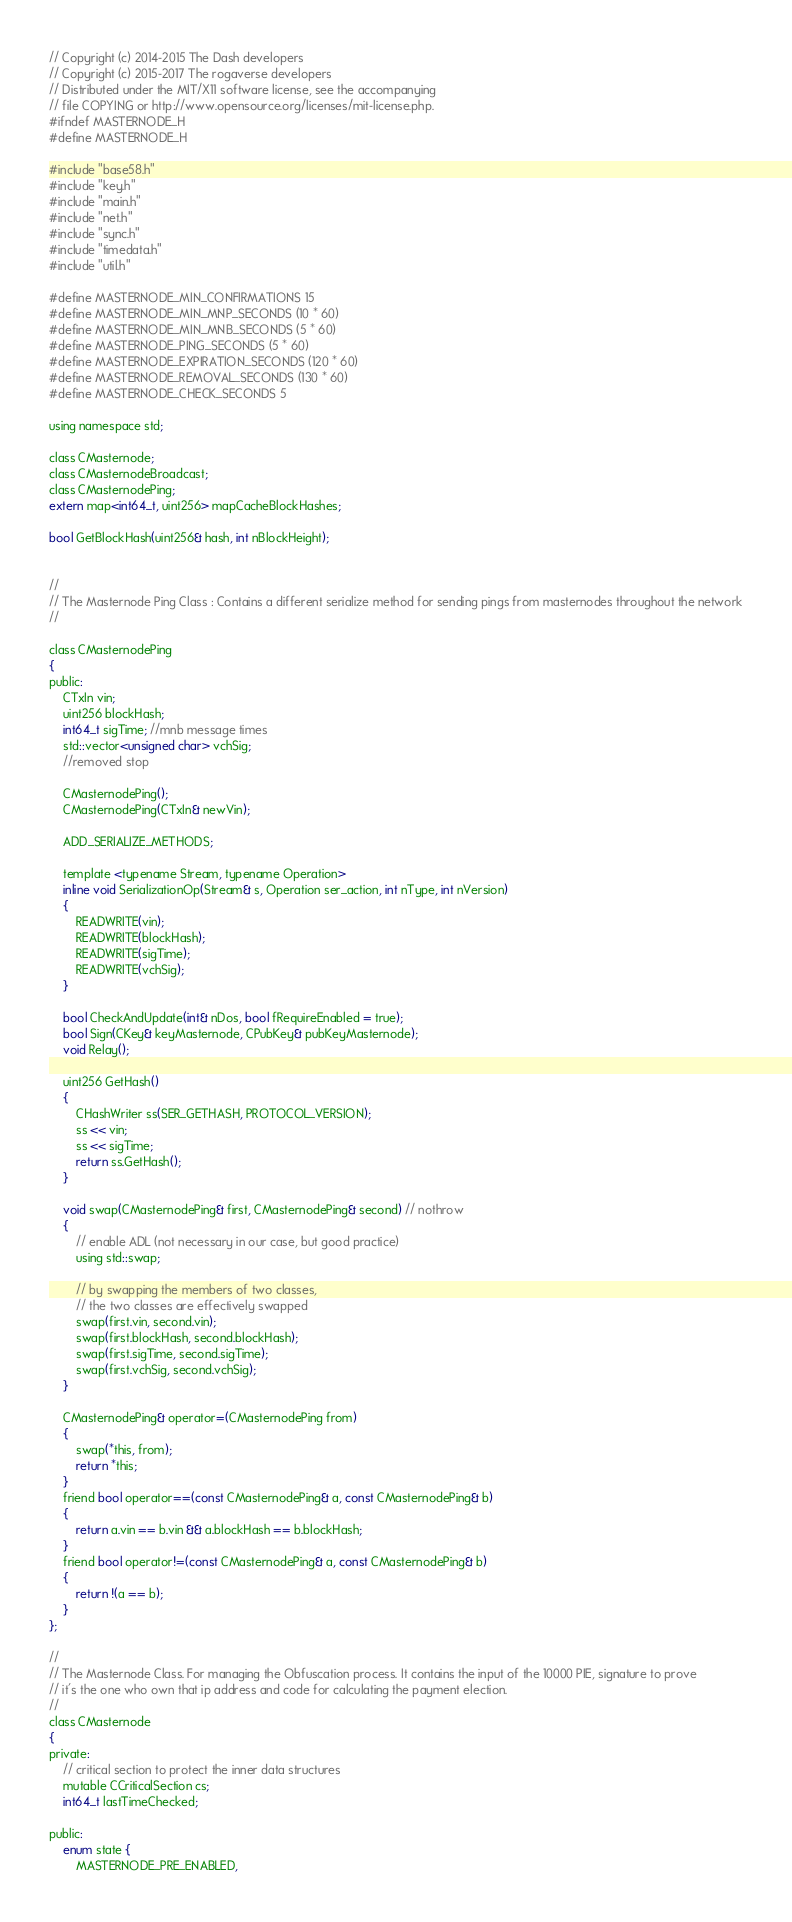<code> <loc_0><loc_0><loc_500><loc_500><_C_>
// Copyright (c) 2014-2015 The Dash developers
// Copyright (c) 2015-2017 The rogaverse developers
// Distributed under the MIT/X11 software license, see the accompanying
// file COPYING or http://www.opensource.org/licenses/mit-license.php.
#ifndef MASTERNODE_H
#define MASTERNODE_H

#include "base58.h"
#include "key.h"
#include "main.h"
#include "net.h"
#include "sync.h"
#include "timedata.h"
#include "util.h"

#define MASTERNODE_MIN_CONFIRMATIONS 15
#define MASTERNODE_MIN_MNP_SECONDS (10 * 60)
#define MASTERNODE_MIN_MNB_SECONDS (5 * 60)
#define MASTERNODE_PING_SECONDS (5 * 60)
#define MASTERNODE_EXPIRATION_SECONDS (120 * 60)
#define MASTERNODE_REMOVAL_SECONDS (130 * 60)
#define MASTERNODE_CHECK_SECONDS 5

using namespace std;

class CMasternode;
class CMasternodeBroadcast;
class CMasternodePing;
extern map<int64_t, uint256> mapCacheBlockHashes;

bool GetBlockHash(uint256& hash, int nBlockHeight);


//
// The Masternode Ping Class : Contains a different serialize method for sending pings from masternodes throughout the network
//

class CMasternodePing
{
public:
    CTxIn vin;
    uint256 blockHash;
    int64_t sigTime; //mnb message times
    std::vector<unsigned char> vchSig;
    //removed stop

    CMasternodePing();
    CMasternodePing(CTxIn& newVin);

    ADD_SERIALIZE_METHODS;

    template <typename Stream, typename Operation>
    inline void SerializationOp(Stream& s, Operation ser_action, int nType, int nVersion)
    {
        READWRITE(vin);
        READWRITE(blockHash);
        READWRITE(sigTime);
        READWRITE(vchSig);
    }

    bool CheckAndUpdate(int& nDos, bool fRequireEnabled = true);
    bool Sign(CKey& keyMasternode, CPubKey& pubKeyMasternode);
    void Relay();

    uint256 GetHash()
    {
        CHashWriter ss(SER_GETHASH, PROTOCOL_VERSION);
        ss << vin;
        ss << sigTime;
        return ss.GetHash();
    }

    void swap(CMasternodePing& first, CMasternodePing& second) // nothrow
    {
        // enable ADL (not necessary in our case, but good practice)
        using std::swap;

        // by swapping the members of two classes,
        // the two classes are effectively swapped
        swap(first.vin, second.vin);
        swap(first.blockHash, second.blockHash);
        swap(first.sigTime, second.sigTime);
        swap(first.vchSig, second.vchSig);
    }

    CMasternodePing& operator=(CMasternodePing from)
    {
        swap(*this, from);
        return *this;
    }
    friend bool operator==(const CMasternodePing& a, const CMasternodePing& b)
    {
        return a.vin == b.vin && a.blockHash == b.blockHash;
    }
    friend bool operator!=(const CMasternodePing& a, const CMasternodePing& b)
    {
        return !(a == b);
    }
};

//
// The Masternode Class. For managing the Obfuscation process. It contains the input of the 10000 PIE, signature to prove
// it's the one who own that ip address and code for calculating the payment election.
//
class CMasternode
{
private:
    // critical section to protect the inner data structures
    mutable CCriticalSection cs;
    int64_t lastTimeChecked;

public:
    enum state {
        MASTERNODE_PRE_ENABLED,</code> 